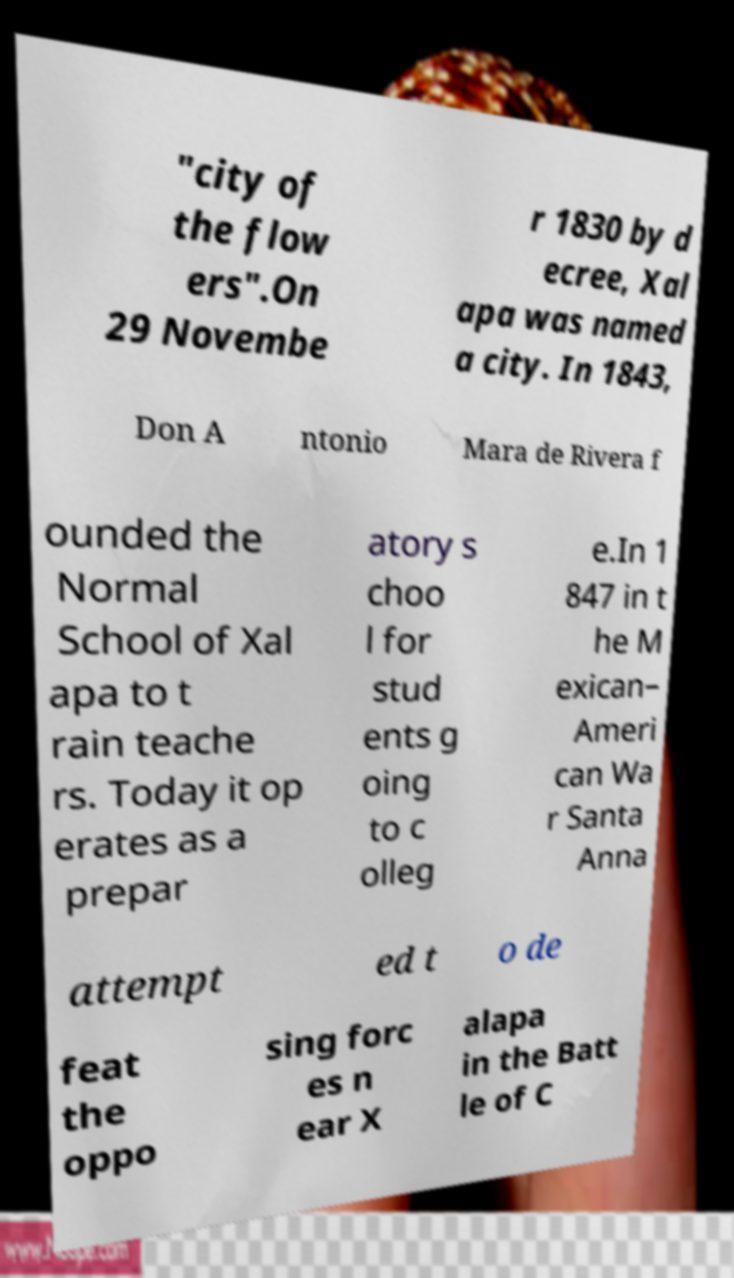Can you read and provide the text displayed in the image?This photo seems to have some interesting text. Can you extract and type it out for me? "city of the flow ers".On 29 Novembe r 1830 by d ecree, Xal apa was named a city. In 1843, Don A ntonio Mara de Rivera f ounded the Normal School of Xal apa to t rain teache rs. Today it op erates as a prepar atory s choo l for stud ents g oing to c olleg e.In 1 847 in t he M exican– Ameri can Wa r Santa Anna attempt ed t o de feat the oppo sing forc es n ear X alapa in the Batt le of C 